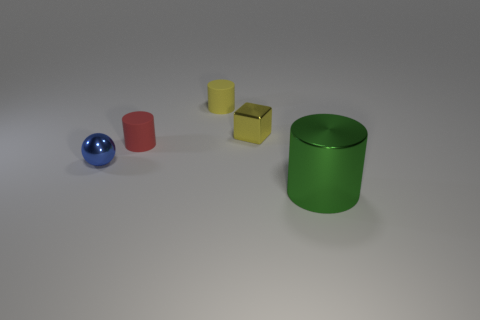There is a small object that is the same material as the small block; what is its shape?
Ensure brevity in your answer.  Sphere. What is the color of the metal object that is both to the right of the small blue shiny sphere and left of the large green object?
Provide a succinct answer. Yellow. What is the size of the rubber cylinder in front of the small rubber thing right of the small red cylinder?
Provide a short and direct response. Small. Are there any tiny metallic balls that have the same color as the large metal object?
Make the answer very short. No. Is the number of tiny blue spheres that are on the right side of the tiny block the same as the number of large purple shiny objects?
Offer a terse response. Yes. How many yellow matte cylinders are there?
Your answer should be very brief. 1. There is a metal object that is on the left side of the big cylinder and in front of the red cylinder; what is its shape?
Your answer should be compact. Sphere. Do the tiny metal thing right of the yellow cylinder and the small rubber cylinder that is behind the cube have the same color?
Your answer should be compact. Yes. There is a object that is the same color as the small metal block; what size is it?
Offer a terse response. Small. Is there another yellow block made of the same material as the small block?
Give a very brief answer. No. 